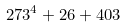Convert formula to latex. <formula><loc_0><loc_0><loc_500><loc_500>2 7 3 ^ { 4 } + 2 6 + 4 0 3</formula> 